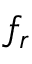Convert formula to latex. <formula><loc_0><loc_0><loc_500><loc_500>f _ { r }</formula> 